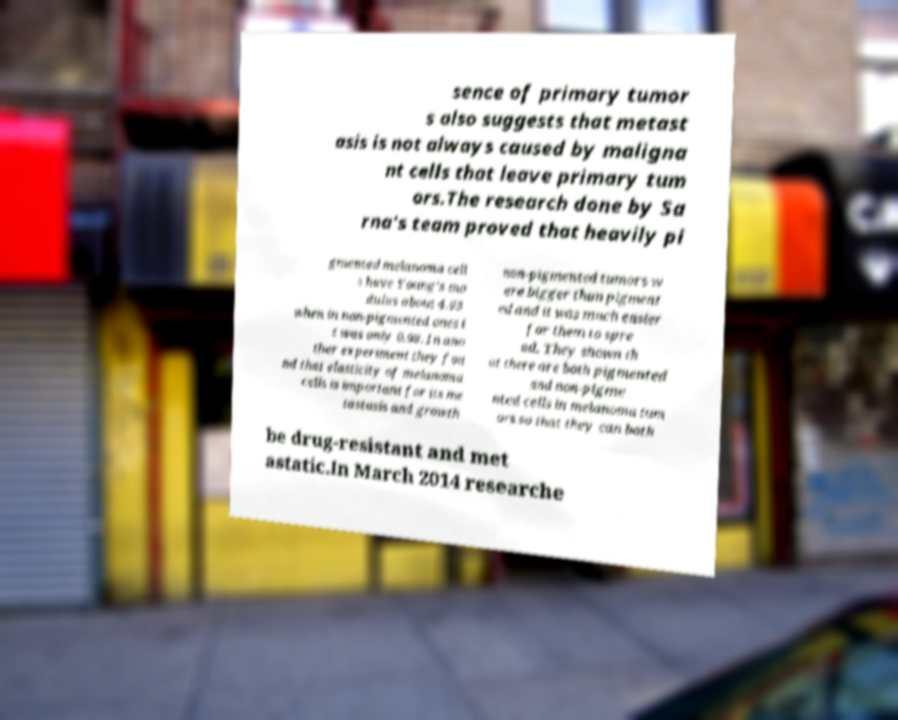Could you extract and type out the text from this image? sence of primary tumor s also suggests that metast asis is not always caused by maligna nt cells that leave primary tum ors.The research done by Sa rna's team proved that heavily pi gmented melanoma cell s have Young's mo dulus about 4.93 when in non-pigmented ones i t was only 0.98. In ano ther experiment they fou nd that elasticity of melanoma cells is important for its me tastasis and growth non-pigmented tumors w ere bigger than pigment ed and it was much easier for them to spre ad. They shown th at there are both pigmented and non-pigme nted cells in melanoma tum ors so that they can both be drug-resistant and met astatic.In March 2014 researche 